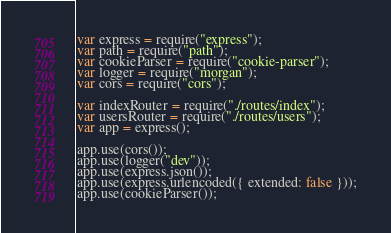Convert code to text. <code><loc_0><loc_0><loc_500><loc_500><_JavaScript_>var express = require("express");
var path = require("path");
var cookieParser = require("cookie-parser");
var logger = require("morgan");
var cors = require("cors");

var indexRouter = require("./routes/index");
var usersRouter = require("./routes/users");
var app = express();

app.use(cors());
app.use(logger("dev"));
app.use(express.json());
app.use(express.urlencoded({ extended: false }));
app.use(cookieParser());</code> 